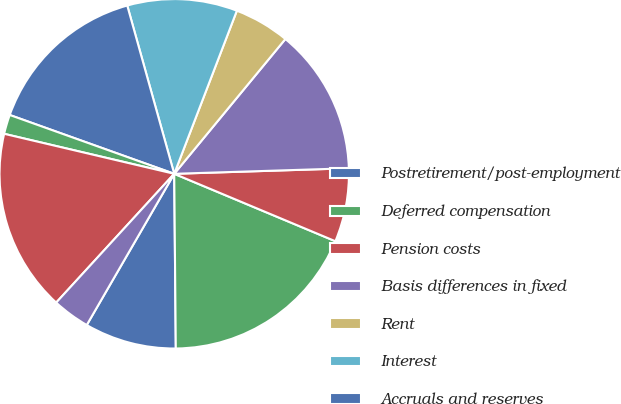Convert chart. <chart><loc_0><loc_0><loc_500><loc_500><pie_chart><fcel>Postretirement/post-employment<fcel>Deferred compensation<fcel>Pension costs<fcel>Basis differences in fixed<fcel>Rent<fcel>Interest<fcel>Accruals and reserves<fcel>Allowance for doubtful<fcel>Basis differences in<fcel>Investments in equity<nl><fcel>8.49%<fcel>18.55%<fcel>6.81%<fcel>13.52%<fcel>5.14%<fcel>10.17%<fcel>15.2%<fcel>1.79%<fcel>16.87%<fcel>3.46%<nl></chart> 